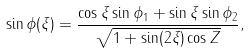Convert formula to latex. <formula><loc_0><loc_0><loc_500><loc_500>\sin \phi ( \xi ) = \frac { \cos \xi \sin \phi _ { 1 } + \sin \xi \sin \phi _ { 2 } } { \sqrt { 1 + \sin ( 2 \xi ) \cos Z } } ,</formula> 